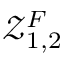<formula> <loc_0><loc_0><loc_500><loc_500>\mathcal { Z } _ { 1 , 2 } ^ { F }</formula> 